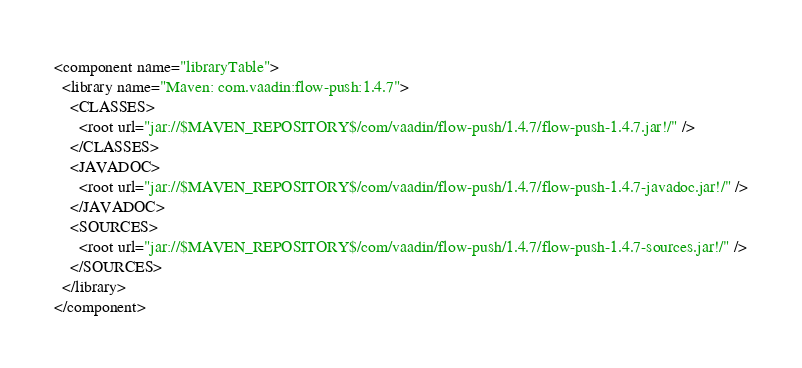<code> <loc_0><loc_0><loc_500><loc_500><_XML_><component name="libraryTable">
  <library name="Maven: com.vaadin:flow-push:1.4.7">
    <CLASSES>
      <root url="jar://$MAVEN_REPOSITORY$/com/vaadin/flow-push/1.4.7/flow-push-1.4.7.jar!/" />
    </CLASSES>
    <JAVADOC>
      <root url="jar://$MAVEN_REPOSITORY$/com/vaadin/flow-push/1.4.7/flow-push-1.4.7-javadoc.jar!/" />
    </JAVADOC>
    <SOURCES>
      <root url="jar://$MAVEN_REPOSITORY$/com/vaadin/flow-push/1.4.7/flow-push-1.4.7-sources.jar!/" />
    </SOURCES>
  </library>
</component></code> 